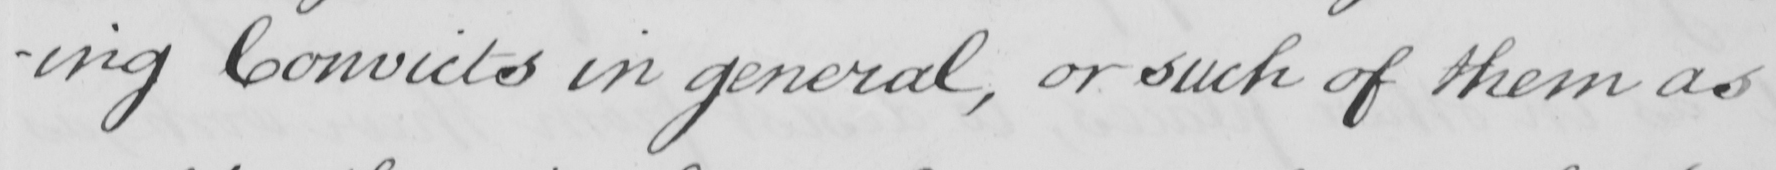What text is written in this handwritten line? -ing Convicts in general , or such of them as 